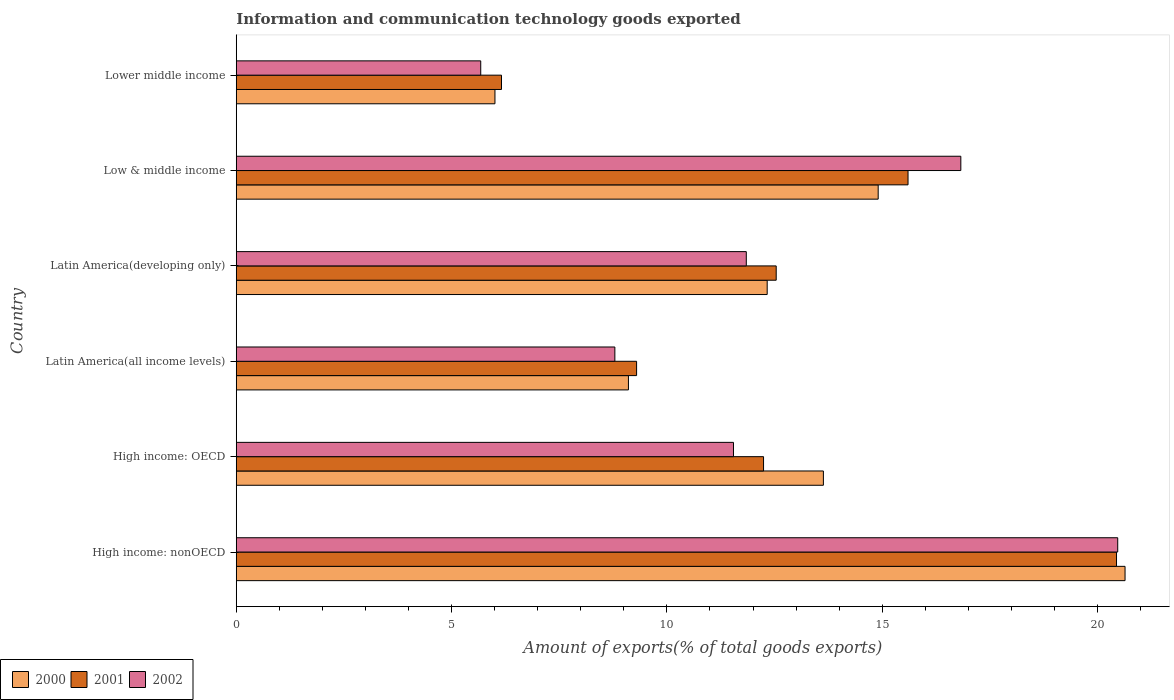How many groups of bars are there?
Keep it short and to the point. 6. Are the number of bars per tick equal to the number of legend labels?
Offer a very short reply. Yes. Are the number of bars on each tick of the Y-axis equal?
Your response must be concise. Yes. How many bars are there on the 1st tick from the bottom?
Ensure brevity in your answer.  3. What is the label of the 1st group of bars from the top?
Your answer should be compact. Lower middle income. What is the amount of goods exported in 2001 in Lower middle income?
Keep it short and to the point. 6.16. Across all countries, what is the maximum amount of goods exported in 2000?
Your answer should be very brief. 20.64. Across all countries, what is the minimum amount of goods exported in 2002?
Offer a terse response. 5.68. In which country was the amount of goods exported in 2001 maximum?
Keep it short and to the point. High income: nonOECD. In which country was the amount of goods exported in 2002 minimum?
Your answer should be compact. Lower middle income. What is the total amount of goods exported in 2001 in the graph?
Give a very brief answer. 76.27. What is the difference between the amount of goods exported in 2002 in Latin America(all income levels) and that in Low & middle income?
Provide a succinct answer. -8.03. What is the difference between the amount of goods exported in 2000 in Latin America(developing only) and the amount of goods exported in 2001 in Low & middle income?
Provide a short and direct response. -3.27. What is the average amount of goods exported in 2001 per country?
Your answer should be very brief. 12.71. What is the difference between the amount of goods exported in 2001 and amount of goods exported in 2002 in Latin America(all income levels)?
Offer a very short reply. 0.5. What is the ratio of the amount of goods exported in 2000 in High income: OECD to that in High income: nonOECD?
Your answer should be compact. 0.66. What is the difference between the highest and the second highest amount of goods exported in 2002?
Ensure brevity in your answer.  3.64. What is the difference between the highest and the lowest amount of goods exported in 2002?
Your answer should be compact. 14.79. Is the sum of the amount of goods exported in 2002 in High income: OECD and Latin America(developing only) greater than the maximum amount of goods exported in 2001 across all countries?
Give a very brief answer. Yes. What does the 2nd bar from the top in Low & middle income represents?
Give a very brief answer. 2001. What does the 2nd bar from the bottom in Low & middle income represents?
Offer a terse response. 2001. How many countries are there in the graph?
Your answer should be very brief. 6. Does the graph contain any zero values?
Ensure brevity in your answer.  No. Does the graph contain grids?
Keep it short and to the point. No. What is the title of the graph?
Ensure brevity in your answer.  Information and communication technology goods exported. Does "1972" appear as one of the legend labels in the graph?
Provide a short and direct response. No. What is the label or title of the X-axis?
Offer a terse response. Amount of exports(% of total goods exports). What is the Amount of exports(% of total goods exports) in 2000 in High income: nonOECD?
Make the answer very short. 20.64. What is the Amount of exports(% of total goods exports) in 2001 in High income: nonOECD?
Make the answer very short. 20.44. What is the Amount of exports(% of total goods exports) of 2002 in High income: nonOECD?
Provide a succinct answer. 20.47. What is the Amount of exports(% of total goods exports) of 2000 in High income: OECD?
Your response must be concise. 13.63. What is the Amount of exports(% of total goods exports) of 2001 in High income: OECD?
Provide a succinct answer. 12.24. What is the Amount of exports(% of total goods exports) in 2002 in High income: OECD?
Ensure brevity in your answer.  11.55. What is the Amount of exports(% of total goods exports) in 2000 in Latin America(all income levels)?
Ensure brevity in your answer.  9.11. What is the Amount of exports(% of total goods exports) in 2001 in Latin America(all income levels)?
Keep it short and to the point. 9.3. What is the Amount of exports(% of total goods exports) of 2002 in Latin America(all income levels)?
Offer a very short reply. 8.79. What is the Amount of exports(% of total goods exports) in 2000 in Latin America(developing only)?
Your answer should be very brief. 12.33. What is the Amount of exports(% of total goods exports) of 2001 in Latin America(developing only)?
Keep it short and to the point. 12.54. What is the Amount of exports(% of total goods exports) of 2002 in Latin America(developing only)?
Provide a short and direct response. 11.84. What is the Amount of exports(% of total goods exports) of 2000 in Low & middle income?
Provide a short and direct response. 14.91. What is the Amount of exports(% of total goods exports) in 2001 in Low & middle income?
Your response must be concise. 15.6. What is the Amount of exports(% of total goods exports) of 2002 in Low & middle income?
Provide a succinct answer. 16.82. What is the Amount of exports(% of total goods exports) of 2000 in Lower middle income?
Offer a very short reply. 6.01. What is the Amount of exports(% of total goods exports) of 2001 in Lower middle income?
Make the answer very short. 6.16. What is the Amount of exports(% of total goods exports) of 2002 in Lower middle income?
Give a very brief answer. 5.68. Across all countries, what is the maximum Amount of exports(% of total goods exports) of 2000?
Make the answer very short. 20.64. Across all countries, what is the maximum Amount of exports(% of total goods exports) of 2001?
Your answer should be compact. 20.44. Across all countries, what is the maximum Amount of exports(% of total goods exports) in 2002?
Provide a succinct answer. 20.47. Across all countries, what is the minimum Amount of exports(% of total goods exports) of 2000?
Give a very brief answer. 6.01. Across all countries, what is the minimum Amount of exports(% of total goods exports) of 2001?
Keep it short and to the point. 6.16. Across all countries, what is the minimum Amount of exports(% of total goods exports) of 2002?
Keep it short and to the point. 5.68. What is the total Amount of exports(% of total goods exports) of 2000 in the graph?
Keep it short and to the point. 76.62. What is the total Amount of exports(% of total goods exports) of 2001 in the graph?
Offer a terse response. 76.27. What is the total Amount of exports(% of total goods exports) in 2002 in the graph?
Provide a succinct answer. 75.15. What is the difference between the Amount of exports(% of total goods exports) of 2000 in High income: nonOECD and that in High income: OECD?
Your answer should be compact. 7. What is the difference between the Amount of exports(% of total goods exports) of 2001 in High income: nonOECD and that in High income: OECD?
Give a very brief answer. 8.2. What is the difference between the Amount of exports(% of total goods exports) of 2002 in High income: nonOECD and that in High income: OECD?
Ensure brevity in your answer.  8.92. What is the difference between the Amount of exports(% of total goods exports) in 2000 in High income: nonOECD and that in Latin America(all income levels)?
Keep it short and to the point. 11.53. What is the difference between the Amount of exports(% of total goods exports) of 2001 in High income: nonOECD and that in Latin America(all income levels)?
Make the answer very short. 11.14. What is the difference between the Amount of exports(% of total goods exports) of 2002 in High income: nonOECD and that in Latin America(all income levels)?
Offer a very short reply. 11.68. What is the difference between the Amount of exports(% of total goods exports) in 2000 in High income: nonOECD and that in Latin America(developing only)?
Your answer should be compact. 8.31. What is the difference between the Amount of exports(% of total goods exports) in 2001 in High income: nonOECD and that in Latin America(developing only)?
Offer a very short reply. 7.9. What is the difference between the Amount of exports(% of total goods exports) of 2002 in High income: nonOECD and that in Latin America(developing only)?
Your answer should be compact. 8.62. What is the difference between the Amount of exports(% of total goods exports) in 2000 in High income: nonOECD and that in Low & middle income?
Your answer should be very brief. 5.73. What is the difference between the Amount of exports(% of total goods exports) of 2001 in High income: nonOECD and that in Low & middle income?
Your answer should be compact. 4.84. What is the difference between the Amount of exports(% of total goods exports) in 2002 in High income: nonOECD and that in Low & middle income?
Offer a very short reply. 3.64. What is the difference between the Amount of exports(% of total goods exports) of 2000 in High income: nonOECD and that in Lower middle income?
Your answer should be very brief. 14.63. What is the difference between the Amount of exports(% of total goods exports) in 2001 in High income: nonOECD and that in Lower middle income?
Your response must be concise. 14.28. What is the difference between the Amount of exports(% of total goods exports) in 2002 in High income: nonOECD and that in Lower middle income?
Your answer should be compact. 14.79. What is the difference between the Amount of exports(% of total goods exports) in 2000 in High income: OECD and that in Latin America(all income levels)?
Your response must be concise. 4.53. What is the difference between the Amount of exports(% of total goods exports) in 2001 in High income: OECD and that in Latin America(all income levels)?
Provide a short and direct response. 2.95. What is the difference between the Amount of exports(% of total goods exports) in 2002 in High income: OECD and that in Latin America(all income levels)?
Provide a succinct answer. 2.75. What is the difference between the Amount of exports(% of total goods exports) of 2000 in High income: OECD and that in Latin America(developing only)?
Make the answer very short. 1.3. What is the difference between the Amount of exports(% of total goods exports) of 2001 in High income: OECD and that in Latin America(developing only)?
Offer a terse response. -0.29. What is the difference between the Amount of exports(% of total goods exports) in 2002 in High income: OECD and that in Latin America(developing only)?
Your answer should be compact. -0.3. What is the difference between the Amount of exports(% of total goods exports) of 2000 in High income: OECD and that in Low & middle income?
Provide a short and direct response. -1.27. What is the difference between the Amount of exports(% of total goods exports) of 2001 in High income: OECD and that in Low & middle income?
Provide a short and direct response. -3.36. What is the difference between the Amount of exports(% of total goods exports) in 2002 in High income: OECD and that in Low & middle income?
Your answer should be compact. -5.28. What is the difference between the Amount of exports(% of total goods exports) in 2000 in High income: OECD and that in Lower middle income?
Ensure brevity in your answer.  7.63. What is the difference between the Amount of exports(% of total goods exports) of 2001 in High income: OECD and that in Lower middle income?
Offer a very short reply. 6.08. What is the difference between the Amount of exports(% of total goods exports) of 2002 in High income: OECD and that in Lower middle income?
Offer a very short reply. 5.87. What is the difference between the Amount of exports(% of total goods exports) of 2000 in Latin America(all income levels) and that in Latin America(developing only)?
Your response must be concise. -3.22. What is the difference between the Amount of exports(% of total goods exports) of 2001 in Latin America(all income levels) and that in Latin America(developing only)?
Keep it short and to the point. -3.24. What is the difference between the Amount of exports(% of total goods exports) of 2002 in Latin America(all income levels) and that in Latin America(developing only)?
Your answer should be very brief. -3.05. What is the difference between the Amount of exports(% of total goods exports) of 2000 in Latin America(all income levels) and that in Low & middle income?
Your answer should be compact. -5.8. What is the difference between the Amount of exports(% of total goods exports) in 2001 in Latin America(all income levels) and that in Low & middle income?
Make the answer very short. -6.3. What is the difference between the Amount of exports(% of total goods exports) of 2002 in Latin America(all income levels) and that in Low & middle income?
Your answer should be very brief. -8.03. What is the difference between the Amount of exports(% of total goods exports) of 2000 in Latin America(all income levels) and that in Lower middle income?
Your answer should be very brief. 3.1. What is the difference between the Amount of exports(% of total goods exports) of 2001 in Latin America(all income levels) and that in Lower middle income?
Provide a succinct answer. 3.14. What is the difference between the Amount of exports(% of total goods exports) in 2002 in Latin America(all income levels) and that in Lower middle income?
Provide a short and direct response. 3.11. What is the difference between the Amount of exports(% of total goods exports) in 2000 in Latin America(developing only) and that in Low & middle income?
Keep it short and to the point. -2.58. What is the difference between the Amount of exports(% of total goods exports) in 2001 in Latin America(developing only) and that in Low & middle income?
Offer a terse response. -3.06. What is the difference between the Amount of exports(% of total goods exports) in 2002 in Latin America(developing only) and that in Low & middle income?
Offer a very short reply. -4.98. What is the difference between the Amount of exports(% of total goods exports) in 2000 in Latin America(developing only) and that in Lower middle income?
Provide a succinct answer. 6.32. What is the difference between the Amount of exports(% of total goods exports) in 2001 in Latin America(developing only) and that in Lower middle income?
Your answer should be very brief. 6.38. What is the difference between the Amount of exports(% of total goods exports) in 2002 in Latin America(developing only) and that in Lower middle income?
Offer a very short reply. 6.17. What is the difference between the Amount of exports(% of total goods exports) in 2000 in Low & middle income and that in Lower middle income?
Your answer should be very brief. 8.9. What is the difference between the Amount of exports(% of total goods exports) of 2001 in Low & middle income and that in Lower middle income?
Ensure brevity in your answer.  9.44. What is the difference between the Amount of exports(% of total goods exports) in 2002 in Low & middle income and that in Lower middle income?
Your answer should be very brief. 11.15. What is the difference between the Amount of exports(% of total goods exports) in 2000 in High income: nonOECD and the Amount of exports(% of total goods exports) in 2001 in High income: OECD?
Give a very brief answer. 8.39. What is the difference between the Amount of exports(% of total goods exports) of 2000 in High income: nonOECD and the Amount of exports(% of total goods exports) of 2002 in High income: OECD?
Make the answer very short. 9.09. What is the difference between the Amount of exports(% of total goods exports) of 2001 in High income: nonOECD and the Amount of exports(% of total goods exports) of 2002 in High income: OECD?
Make the answer very short. 8.89. What is the difference between the Amount of exports(% of total goods exports) in 2000 in High income: nonOECD and the Amount of exports(% of total goods exports) in 2001 in Latin America(all income levels)?
Your answer should be compact. 11.34. What is the difference between the Amount of exports(% of total goods exports) in 2000 in High income: nonOECD and the Amount of exports(% of total goods exports) in 2002 in Latin America(all income levels)?
Provide a short and direct response. 11.85. What is the difference between the Amount of exports(% of total goods exports) of 2001 in High income: nonOECD and the Amount of exports(% of total goods exports) of 2002 in Latin America(all income levels)?
Give a very brief answer. 11.65. What is the difference between the Amount of exports(% of total goods exports) in 2000 in High income: nonOECD and the Amount of exports(% of total goods exports) in 2001 in Latin America(developing only)?
Provide a short and direct response. 8.1. What is the difference between the Amount of exports(% of total goods exports) in 2000 in High income: nonOECD and the Amount of exports(% of total goods exports) in 2002 in Latin America(developing only)?
Make the answer very short. 8.79. What is the difference between the Amount of exports(% of total goods exports) in 2001 in High income: nonOECD and the Amount of exports(% of total goods exports) in 2002 in Latin America(developing only)?
Offer a terse response. 8.6. What is the difference between the Amount of exports(% of total goods exports) of 2000 in High income: nonOECD and the Amount of exports(% of total goods exports) of 2001 in Low & middle income?
Offer a very short reply. 5.04. What is the difference between the Amount of exports(% of total goods exports) in 2000 in High income: nonOECD and the Amount of exports(% of total goods exports) in 2002 in Low & middle income?
Your response must be concise. 3.81. What is the difference between the Amount of exports(% of total goods exports) in 2001 in High income: nonOECD and the Amount of exports(% of total goods exports) in 2002 in Low & middle income?
Ensure brevity in your answer.  3.61. What is the difference between the Amount of exports(% of total goods exports) in 2000 in High income: nonOECD and the Amount of exports(% of total goods exports) in 2001 in Lower middle income?
Your response must be concise. 14.48. What is the difference between the Amount of exports(% of total goods exports) in 2000 in High income: nonOECD and the Amount of exports(% of total goods exports) in 2002 in Lower middle income?
Keep it short and to the point. 14.96. What is the difference between the Amount of exports(% of total goods exports) in 2001 in High income: nonOECD and the Amount of exports(% of total goods exports) in 2002 in Lower middle income?
Ensure brevity in your answer.  14.76. What is the difference between the Amount of exports(% of total goods exports) in 2000 in High income: OECD and the Amount of exports(% of total goods exports) in 2001 in Latin America(all income levels)?
Provide a succinct answer. 4.34. What is the difference between the Amount of exports(% of total goods exports) of 2000 in High income: OECD and the Amount of exports(% of total goods exports) of 2002 in Latin America(all income levels)?
Ensure brevity in your answer.  4.84. What is the difference between the Amount of exports(% of total goods exports) of 2001 in High income: OECD and the Amount of exports(% of total goods exports) of 2002 in Latin America(all income levels)?
Keep it short and to the point. 3.45. What is the difference between the Amount of exports(% of total goods exports) in 2000 in High income: OECD and the Amount of exports(% of total goods exports) in 2001 in Latin America(developing only)?
Keep it short and to the point. 1.1. What is the difference between the Amount of exports(% of total goods exports) in 2000 in High income: OECD and the Amount of exports(% of total goods exports) in 2002 in Latin America(developing only)?
Your answer should be very brief. 1.79. What is the difference between the Amount of exports(% of total goods exports) in 2001 in High income: OECD and the Amount of exports(% of total goods exports) in 2002 in Latin America(developing only)?
Offer a terse response. 0.4. What is the difference between the Amount of exports(% of total goods exports) in 2000 in High income: OECD and the Amount of exports(% of total goods exports) in 2001 in Low & middle income?
Offer a very short reply. -1.97. What is the difference between the Amount of exports(% of total goods exports) in 2000 in High income: OECD and the Amount of exports(% of total goods exports) in 2002 in Low & middle income?
Your answer should be very brief. -3.19. What is the difference between the Amount of exports(% of total goods exports) of 2001 in High income: OECD and the Amount of exports(% of total goods exports) of 2002 in Low & middle income?
Offer a very short reply. -4.58. What is the difference between the Amount of exports(% of total goods exports) of 2000 in High income: OECD and the Amount of exports(% of total goods exports) of 2001 in Lower middle income?
Provide a short and direct response. 7.47. What is the difference between the Amount of exports(% of total goods exports) of 2000 in High income: OECD and the Amount of exports(% of total goods exports) of 2002 in Lower middle income?
Offer a very short reply. 7.96. What is the difference between the Amount of exports(% of total goods exports) of 2001 in High income: OECD and the Amount of exports(% of total goods exports) of 2002 in Lower middle income?
Ensure brevity in your answer.  6.57. What is the difference between the Amount of exports(% of total goods exports) in 2000 in Latin America(all income levels) and the Amount of exports(% of total goods exports) in 2001 in Latin America(developing only)?
Provide a succinct answer. -3.43. What is the difference between the Amount of exports(% of total goods exports) of 2000 in Latin America(all income levels) and the Amount of exports(% of total goods exports) of 2002 in Latin America(developing only)?
Make the answer very short. -2.74. What is the difference between the Amount of exports(% of total goods exports) of 2001 in Latin America(all income levels) and the Amount of exports(% of total goods exports) of 2002 in Latin America(developing only)?
Make the answer very short. -2.55. What is the difference between the Amount of exports(% of total goods exports) of 2000 in Latin America(all income levels) and the Amount of exports(% of total goods exports) of 2001 in Low & middle income?
Your answer should be compact. -6.49. What is the difference between the Amount of exports(% of total goods exports) in 2000 in Latin America(all income levels) and the Amount of exports(% of total goods exports) in 2002 in Low & middle income?
Ensure brevity in your answer.  -7.72. What is the difference between the Amount of exports(% of total goods exports) of 2001 in Latin America(all income levels) and the Amount of exports(% of total goods exports) of 2002 in Low & middle income?
Ensure brevity in your answer.  -7.53. What is the difference between the Amount of exports(% of total goods exports) in 2000 in Latin America(all income levels) and the Amount of exports(% of total goods exports) in 2001 in Lower middle income?
Provide a short and direct response. 2.95. What is the difference between the Amount of exports(% of total goods exports) in 2000 in Latin America(all income levels) and the Amount of exports(% of total goods exports) in 2002 in Lower middle income?
Provide a short and direct response. 3.43. What is the difference between the Amount of exports(% of total goods exports) in 2001 in Latin America(all income levels) and the Amount of exports(% of total goods exports) in 2002 in Lower middle income?
Your answer should be compact. 3.62. What is the difference between the Amount of exports(% of total goods exports) in 2000 in Latin America(developing only) and the Amount of exports(% of total goods exports) in 2001 in Low & middle income?
Your response must be concise. -3.27. What is the difference between the Amount of exports(% of total goods exports) of 2000 in Latin America(developing only) and the Amount of exports(% of total goods exports) of 2002 in Low & middle income?
Provide a short and direct response. -4.5. What is the difference between the Amount of exports(% of total goods exports) of 2001 in Latin America(developing only) and the Amount of exports(% of total goods exports) of 2002 in Low & middle income?
Provide a succinct answer. -4.29. What is the difference between the Amount of exports(% of total goods exports) in 2000 in Latin America(developing only) and the Amount of exports(% of total goods exports) in 2001 in Lower middle income?
Offer a terse response. 6.17. What is the difference between the Amount of exports(% of total goods exports) of 2000 in Latin America(developing only) and the Amount of exports(% of total goods exports) of 2002 in Lower middle income?
Offer a very short reply. 6.65. What is the difference between the Amount of exports(% of total goods exports) in 2001 in Latin America(developing only) and the Amount of exports(% of total goods exports) in 2002 in Lower middle income?
Your answer should be compact. 6.86. What is the difference between the Amount of exports(% of total goods exports) in 2000 in Low & middle income and the Amount of exports(% of total goods exports) in 2001 in Lower middle income?
Provide a short and direct response. 8.75. What is the difference between the Amount of exports(% of total goods exports) of 2000 in Low & middle income and the Amount of exports(% of total goods exports) of 2002 in Lower middle income?
Make the answer very short. 9.23. What is the difference between the Amount of exports(% of total goods exports) in 2001 in Low & middle income and the Amount of exports(% of total goods exports) in 2002 in Lower middle income?
Your response must be concise. 9.92. What is the average Amount of exports(% of total goods exports) of 2000 per country?
Offer a very short reply. 12.77. What is the average Amount of exports(% of total goods exports) in 2001 per country?
Provide a succinct answer. 12.71. What is the average Amount of exports(% of total goods exports) of 2002 per country?
Your response must be concise. 12.52. What is the difference between the Amount of exports(% of total goods exports) in 2000 and Amount of exports(% of total goods exports) in 2001 in High income: nonOECD?
Offer a terse response. 0.2. What is the difference between the Amount of exports(% of total goods exports) in 2000 and Amount of exports(% of total goods exports) in 2002 in High income: nonOECD?
Ensure brevity in your answer.  0.17. What is the difference between the Amount of exports(% of total goods exports) of 2001 and Amount of exports(% of total goods exports) of 2002 in High income: nonOECD?
Offer a terse response. -0.03. What is the difference between the Amount of exports(% of total goods exports) of 2000 and Amount of exports(% of total goods exports) of 2001 in High income: OECD?
Offer a terse response. 1.39. What is the difference between the Amount of exports(% of total goods exports) in 2000 and Amount of exports(% of total goods exports) in 2002 in High income: OECD?
Your response must be concise. 2.09. What is the difference between the Amount of exports(% of total goods exports) in 2001 and Amount of exports(% of total goods exports) in 2002 in High income: OECD?
Provide a short and direct response. 0.7. What is the difference between the Amount of exports(% of total goods exports) in 2000 and Amount of exports(% of total goods exports) in 2001 in Latin America(all income levels)?
Provide a short and direct response. -0.19. What is the difference between the Amount of exports(% of total goods exports) of 2000 and Amount of exports(% of total goods exports) of 2002 in Latin America(all income levels)?
Offer a very short reply. 0.32. What is the difference between the Amount of exports(% of total goods exports) of 2001 and Amount of exports(% of total goods exports) of 2002 in Latin America(all income levels)?
Your response must be concise. 0.5. What is the difference between the Amount of exports(% of total goods exports) in 2000 and Amount of exports(% of total goods exports) in 2001 in Latin America(developing only)?
Offer a very short reply. -0.21. What is the difference between the Amount of exports(% of total goods exports) of 2000 and Amount of exports(% of total goods exports) of 2002 in Latin America(developing only)?
Give a very brief answer. 0.49. What is the difference between the Amount of exports(% of total goods exports) of 2001 and Amount of exports(% of total goods exports) of 2002 in Latin America(developing only)?
Offer a very short reply. 0.69. What is the difference between the Amount of exports(% of total goods exports) of 2000 and Amount of exports(% of total goods exports) of 2001 in Low & middle income?
Make the answer very short. -0.69. What is the difference between the Amount of exports(% of total goods exports) in 2000 and Amount of exports(% of total goods exports) in 2002 in Low & middle income?
Keep it short and to the point. -1.92. What is the difference between the Amount of exports(% of total goods exports) in 2001 and Amount of exports(% of total goods exports) in 2002 in Low & middle income?
Your response must be concise. -1.23. What is the difference between the Amount of exports(% of total goods exports) in 2000 and Amount of exports(% of total goods exports) in 2001 in Lower middle income?
Keep it short and to the point. -0.15. What is the difference between the Amount of exports(% of total goods exports) in 2000 and Amount of exports(% of total goods exports) in 2002 in Lower middle income?
Offer a very short reply. 0.33. What is the difference between the Amount of exports(% of total goods exports) of 2001 and Amount of exports(% of total goods exports) of 2002 in Lower middle income?
Make the answer very short. 0.48. What is the ratio of the Amount of exports(% of total goods exports) in 2000 in High income: nonOECD to that in High income: OECD?
Make the answer very short. 1.51. What is the ratio of the Amount of exports(% of total goods exports) in 2001 in High income: nonOECD to that in High income: OECD?
Give a very brief answer. 1.67. What is the ratio of the Amount of exports(% of total goods exports) in 2002 in High income: nonOECD to that in High income: OECD?
Your response must be concise. 1.77. What is the ratio of the Amount of exports(% of total goods exports) of 2000 in High income: nonOECD to that in Latin America(all income levels)?
Provide a succinct answer. 2.27. What is the ratio of the Amount of exports(% of total goods exports) of 2001 in High income: nonOECD to that in Latin America(all income levels)?
Offer a very short reply. 2.2. What is the ratio of the Amount of exports(% of total goods exports) in 2002 in High income: nonOECD to that in Latin America(all income levels)?
Your answer should be very brief. 2.33. What is the ratio of the Amount of exports(% of total goods exports) of 2000 in High income: nonOECD to that in Latin America(developing only)?
Provide a short and direct response. 1.67. What is the ratio of the Amount of exports(% of total goods exports) of 2001 in High income: nonOECD to that in Latin America(developing only)?
Provide a short and direct response. 1.63. What is the ratio of the Amount of exports(% of total goods exports) of 2002 in High income: nonOECD to that in Latin America(developing only)?
Your response must be concise. 1.73. What is the ratio of the Amount of exports(% of total goods exports) of 2000 in High income: nonOECD to that in Low & middle income?
Your answer should be very brief. 1.38. What is the ratio of the Amount of exports(% of total goods exports) in 2001 in High income: nonOECD to that in Low & middle income?
Ensure brevity in your answer.  1.31. What is the ratio of the Amount of exports(% of total goods exports) of 2002 in High income: nonOECD to that in Low & middle income?
Make the answer very short. 1.22. What is the ratio of the Amount of exports(% of total goods exports) in 2000 in High income: nonOECD to that in Lower middle income?
Your response must be concise. 3.44. What is the ratio of the Amount of exports(% of total goods exports) in 2001 in High income: nonOECD to that in Lower middle income?
Give a very brief answer. 3.32. What is the ratio of the Amount of exports(% of total goods exports) in 2002 in High income: nonOECD to that in Lower middle income?
Offer a terse response. 3.61. What is the ratio of the Amount of exports(% of total goods exports) of 2000 in High income: OECD to that in Latin America(all income levels)?
Give a very brief answer. 1.5. What is the ratio of the Amount of exports(% of total goods exports) in 2001 in High income: OECD to that in Latin America(all income levels)?
Ensure brevity in your answer.  1.32. What is the ratio of the Amount of exports(% of total goods exports) in 2002 in High income: OECD to that in Latin America(all income levels)?
Your answer should be very brief. 1.31. What is the ratio of the Amount of exports(% of total goods exports) of 2000 in High income: OECD to that in Latin America(developing only)?
Offer a very short reply. 1.11. What is the ratio of the Amount of exports(% of total goods exports) in 2001 in High income: OECD to that in Latin America(developing only)?
Make the answer very short. 0.98. What is the ratio of the Amount of exports(% of total goods exports) of 2002 in High income: OECD to that in Latin America(developing only)?
Offer a terse response. 0.97. What is the ratio of the Amount of exports(% of total goods exports) in 2000 in High income: OECD to that in Low & middle income?
Your response must be concise. 0.91. What is the ratio of the Amount of exports(% of total goods exports) of 2001 in High income: OECD to that in Low & middle income?
Keep it short and to the point. 0.78. What is the ratio of the Amount of exports(% of total goods exports) of 2002 in High income: OECD to that in Low & middle income?
Offer a terse response. 0.69. What is the ratio of the Amount of exports(% of total goods exports) of 2000 in High income: OECD to that in Lower middle income?
Your answer should be compact. 2.27. What is the ratio of the Amount of exports(% of total goods exports) of 2001 in High income: OECD to that in Lower middle income?
Provide a short and direct response. 1.99. What is the ratio of the Amount of exports(% of total goods exports) of 2002 in High income: OECD to that in Lower middle income?
Offer a terse response. 2.03. What is the ratio of the Amount of exports(% of total goods exports) of 2000 in Latin America(all income levels) to that in Latin America(developing only)?
Make the answer very short. 0.74. What is the ratio of the Amount of exports(% of total goods exports) in 2001 in Latin America(all income levels) to that in Latin America(developing only)?
Provide a succinct answer. 0.74. What is the ratio of the Amount of exports(% of total goods exports) in 2002 in Latin America(all income levels) to that in Latin America(developing only)?
Make the answer very short. 0.74. What is the ratio of the Amount of exports(% of total goods exports) of 2000 in Latin America(all income levels) to that in Low & middle income?
Offer a terse response. 0.61. What is the ratio of the Amount of exports(% of total goods exports) of 2001 in Latin America(all income levels) to that in Low & middle income?
Provide a short and direct response. 0.6. What is the ratio of the Amount of exports(% of total goods exports) of 2002 in Latin America(all income levels) to that in Low & middle income?
Your answer should be very brief. 0.52. What is the ratio of the Amount of exports(% of total goods exports) of 2000 in Latin America(all income levels) to that in Lower middle income?
Give a very brief answer. 1.52. What is the ratio of the Amount of exports(% of total goods exports) of 2001 in Latin America(all income levels) to that in Lower middle income?
Your response must be concise. 1.51. What is the ratio of the Amount of exports(% of total goods exports) of 2002 in Latin America(all income levels) to that in Lower middle income?
Your answer should be compact. 1.55. What is the ratio of the Amount of exports(% of total goods exports) of 2000 in Latin America(developing only) to that in Low & middle income?
Offer a terse response. 0.83. What is the ratio of the Amount of exports(% of total goods exports) in 2001 in Latin America(developing only) to that in Low & middle income?
Offer a terse response. 0.8. What is the ratio of the Amount of exports(% of total goods exports) of 2002 in Latin America(developing only) to that in Low & middle income?
Provide a short and direct response. 0.7. What is the ratio of the Amount of exports(% of total goods exports) of 2000 in Latin America(developing only) to that in Lower middle income?
Offer a terse response. 2.05. What is the ratio of the Amount of exports(% of total goods exports) in 2001 in Latin America(developing only) to that in Lower middle income?
Offer a very short reply. 2.04. What is the ratio of the Amount of exports(% of total goods exports) of 2002 in Latin America(developing only) to that in Lower middle income?
Make the answer very short. 2.09. What is the ratio of the Amount of exports(% of total goods exports) in 2000 in Low & middle income to that in Lower middle income?
Your response must be concise. 2.48. What is the ratio of the Amount of exports(% of total goods exports) of 2001 in Low & middle income to that in Lower middle income?
Make the answer very short. 2.53. What is the ratio of the Amount of exports(% of total goods exports) in 2002 in Low & middle income to that in Lower middle income?
Give a very brief answer. 2.96. What is the difference between the highest and the second highest Amount of exports(% of total goods exports) in 2000?
Ensure brevity in your answer.  5.73. What is the difference between the highest and the second highest Amount of exports(% of total goods exports) in 2001?
Give a very brief answer. 4.84. What is the difference between the highest and the second highest Amount of exports(% of total goods exports) of 2002?
Keep it short and to the point. 3.64. What is the difference between the highest and the lowest Amount of exports(% of total goods exports) in 2000?
Offer a very short reply. 14.63. What is the difference between the highest and the lowest Amount of exports(% of total goods exports) in 2001?
Offer a terse response. 14.28. What is the difference between the highest and the lowest Amount of exports(% of total goods exports) of 2002?
Offer a very short reply. 14.79. 